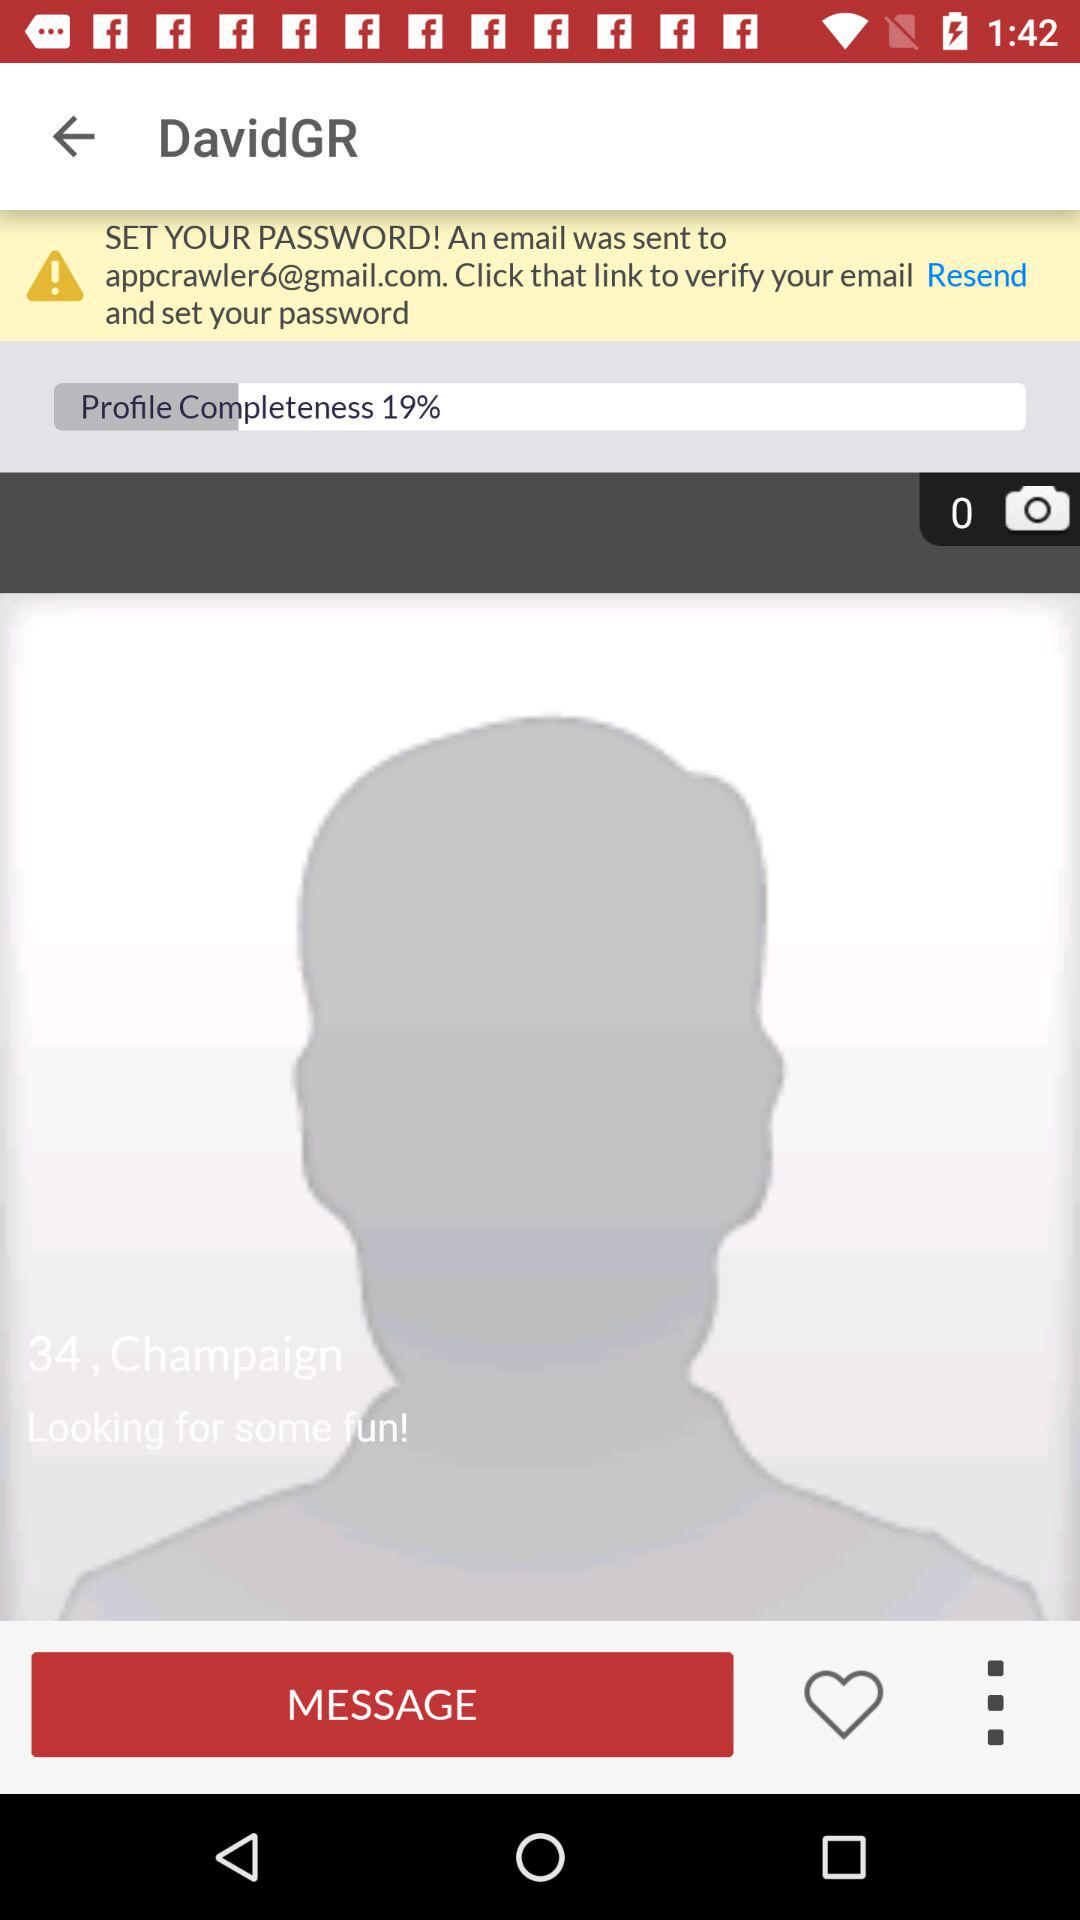What is the mentioned age? The mentioned age is 34. 